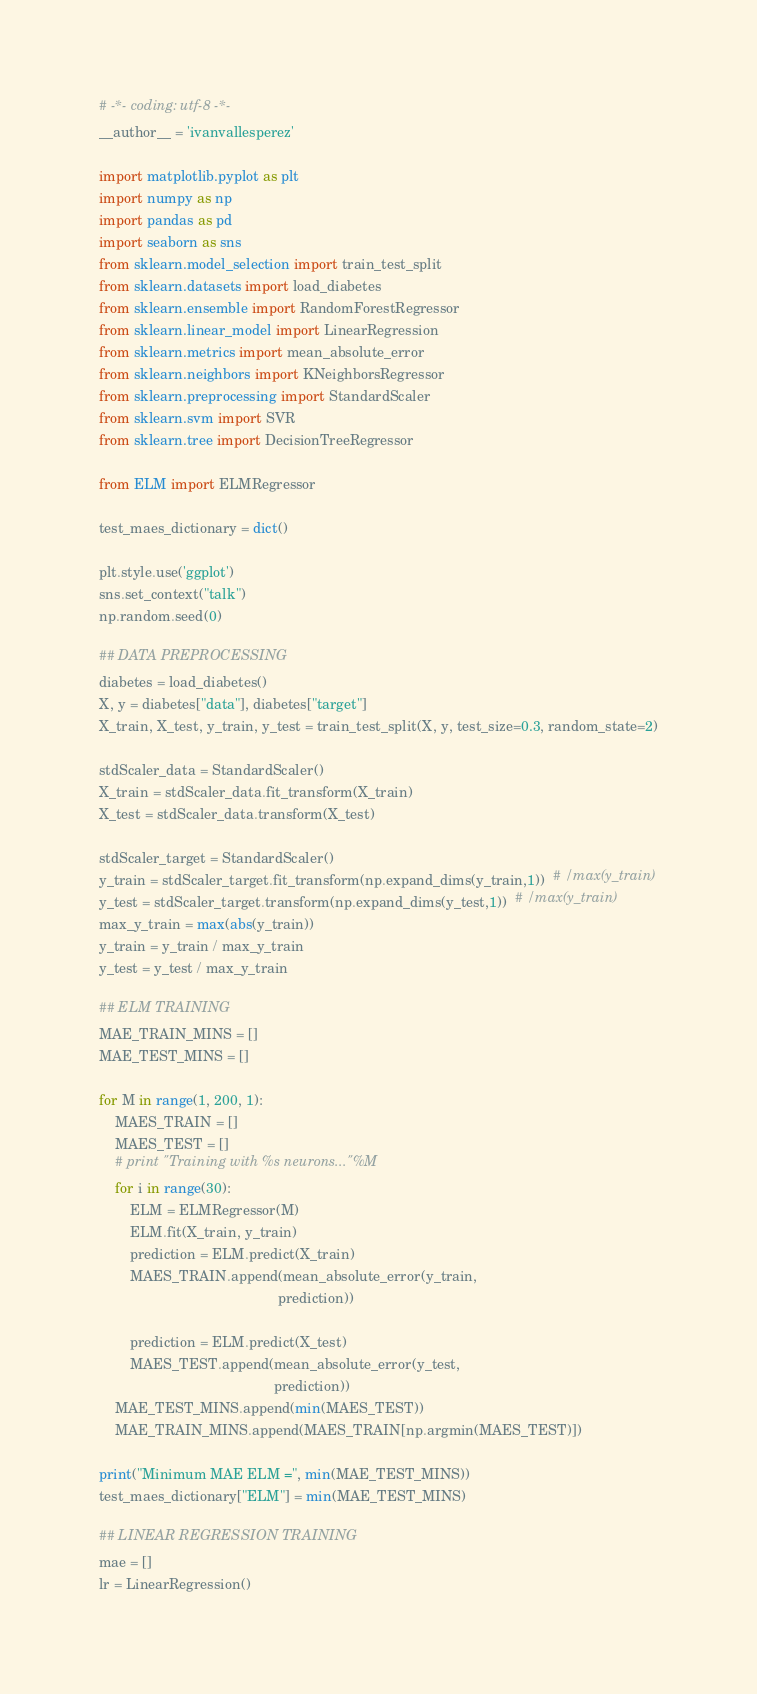Convert code to text. <code><loc_0><loc_0><loc_500><loc_500><_Python_># -*- coding: utf-8 -*-
__author__ = 'ivanvallesperez'

import matplotlib.pyplot as plt
import numpy as np
import pandas as pd
import seaborn as sns
from sklearn.model_selection import train_test_split
from sklearn.datasets import load_diabetes
from sklearn.ensemble import RandomForestRegressor
from sklearn.linear_model import LinearRegression
from sklearn.metrics import mean_absolute_error
from sklearn.neighbors import KNeighborsRegressor
from sklearn.preprocessing import StandardScaler
from sklearn.svm import SVR
from sklearn.tree import DecisionTreeRegressor

from ELM import ELMRegressor

test_maes_dictionary = dict()

plt.style.use('ggplot')
sns.set_context("talk")
np.random.seed(0)

## DATA PREPROCESSING
diabetes = load_diabetes()
X, y = diabetes["data"], diabetes["target"]
X_train, X_test, y_train, y_test = train_test_split(X, y, test_size=0.3, random_state=2)

stdScaler_data = StandardScaler()
X_train = stdScaler_data.fit_transform(X_train)
X_test = stdScaler_data.transform(X_test)

stdScaler_target = StandardScaler()
y_train = stdScaler_target.fit_transform(np.expand_dims(y_train,1))  # /max(y_train)
y_test = stdScaler_target.transform(np.expand_dims(y_test,1))  # /max(y_train)
max_y_train = max(abs(y_train))
y_train = y_train / max_y_train
y_test = y_test / max_y_train

## ELM TRAINING
MAE_TRAIN_MINS = []
MAE_TEST_MINS = []

for M in range(1, 200, 1):
    MAES_TRAIN = []
    MAES_TEST = []
    # print "Training with %s neurons..."%M
    for i in range(30):
        ELM = ELMRegressor(M)
        ELM.fit(X_train, y_train)
        prediction = ELM.predict(X_train)
        MAES_TRAIN.append(mean_absolute_error(y_train,
                                              prediction))

        prediction = ELM.predict(X_test)
        MAES_TEST.append(mean_absolute_error(y_test,
                                             prediction))
    MAE_TEST_MINS.append(min(MAES_TEST))
    MAE_TRAIN_MINS.append(MAES_TRAIN[np.argmin(MAES_TEST)])

print("Minimum MAE ELM =", min(MAE_TEST_MINS))
test_maes_dictionary["ELM"] = min(MAE_TEST_MINS)

## LINEAR REGRESSION TRAINING
mae = []
lr = LinearRegression()</code> 